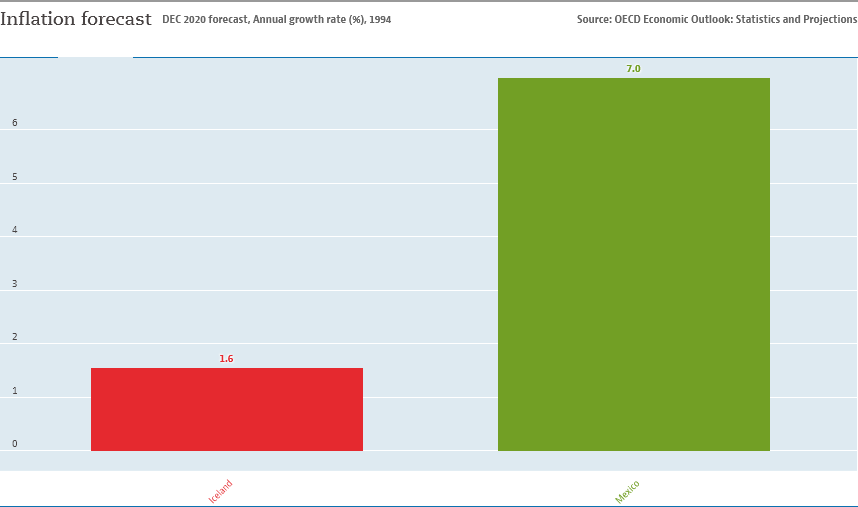Give some essential details in this illustration. The graph contains two places. The sum value of Iceland and Mexico is 8.6. 